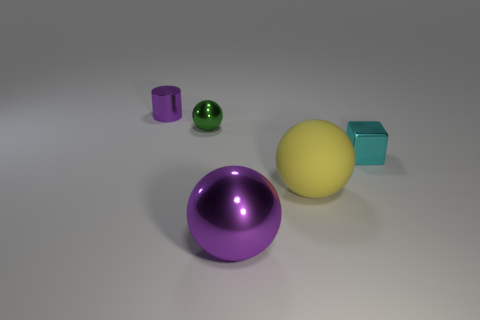Are there the same number of large spheres that are behind the big metal thing and small objects that are behind the small cyan shiny block?
Keep it short and to the point. No. The object that is both to the right of the big metal object and to the left of the cyan shiny block has what shape?
Provide a short and direct response. Sphere. There is a yellow ball; how many tiny metal objects are on the left side of it?
Offer a very short reply. 2. How many other things are the same shape as the small cyan shiny thing?
Make the answer very short. 0. Is the number of big brown objects less than the number of tiny metallic cylinders?
Provide a short and direct response. Yes. There is a thing that is both on the right side of the small purple metallic cylinder and on the left side of the large metallic ball; how big is it?
Your answer should be very brief. Small. There is a purple metallic ball that is on the left side of the tiny metallic block that is to the right of the purple metal object in front of the green thing; how big is it?
Your answer should be very brief. Large. How big is the yellow ball?
Your response must be concise. Large. Are there any other things that have the same material as the cube?
Keep it short and to the point. Yes. There is a purple metallic thing that is on the left side of the ball that is in front of the large yellow sphere; is there a large yellow thing that is left of it?
Give a very brief answer. No. 